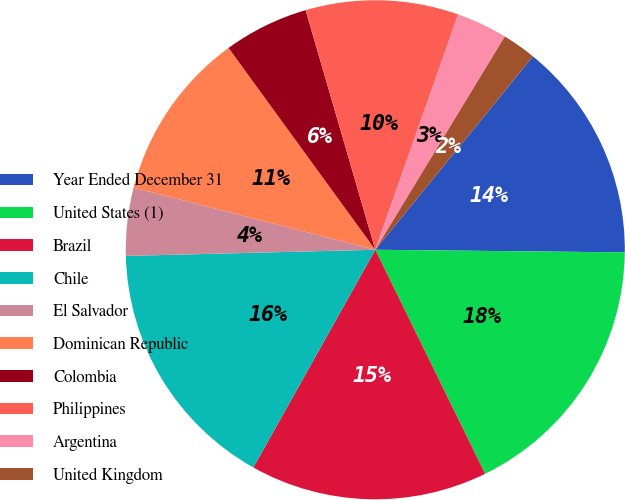Convert chart to OTSL. <chart><loc_0><loc_0><loc_500><loc_500><pie_chart><fcel>Year Ended December 31<fcel>United States (1)<fcel>Brazil<fcel>Chile<fcel>El Salvador<fcel>Dominican Republic<fcel>Colombia<fcel>Philippines<fcel>Argentina<fcel>United Kingdom<nl><fcel>14.28%<fcel>17.58%<fcel>15.38%<fcel>16.48%<fcel>4.4%<fcel>10.99%<fcel>5.5%<fcel>9.89%<fcel>3.3%<fcel>2.2%<nl></chart> 